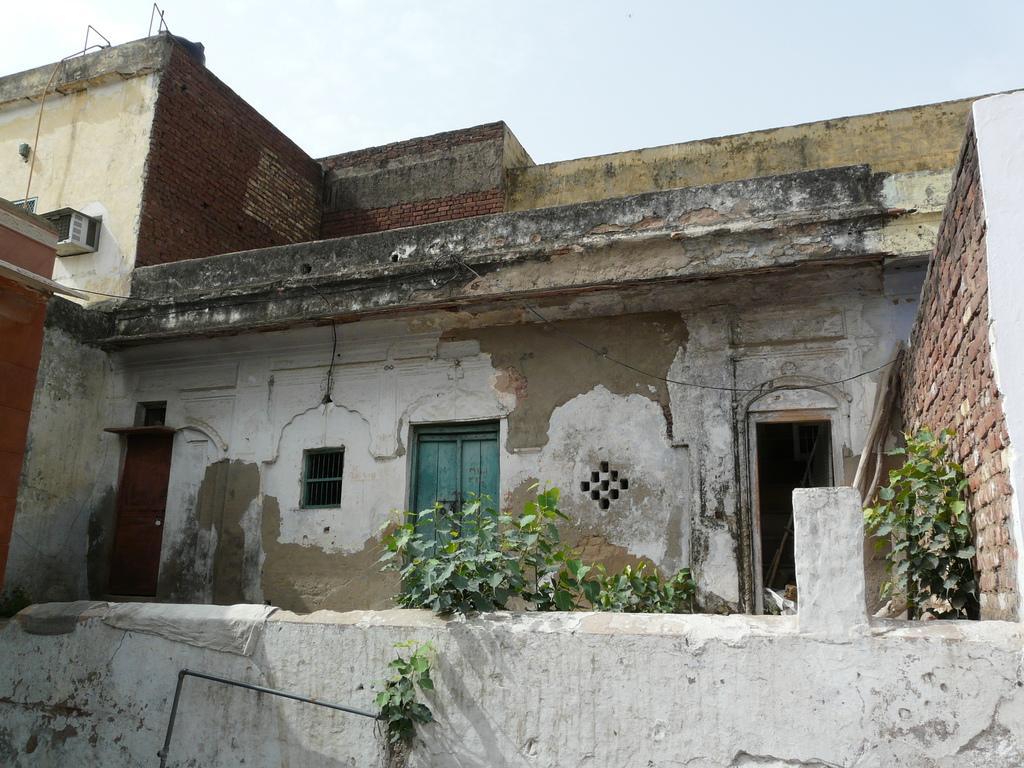Please provide a concise description of this image. This picture might be taken from outside of the house. In this image, in the middle, we can see some plants. In the background, we can see a building, doors. On the right side, we can also see a brick wall and a plant. On the left side, we can see air conditioner. At the top, we can see a sky, at the bottom, we can see a wall. 